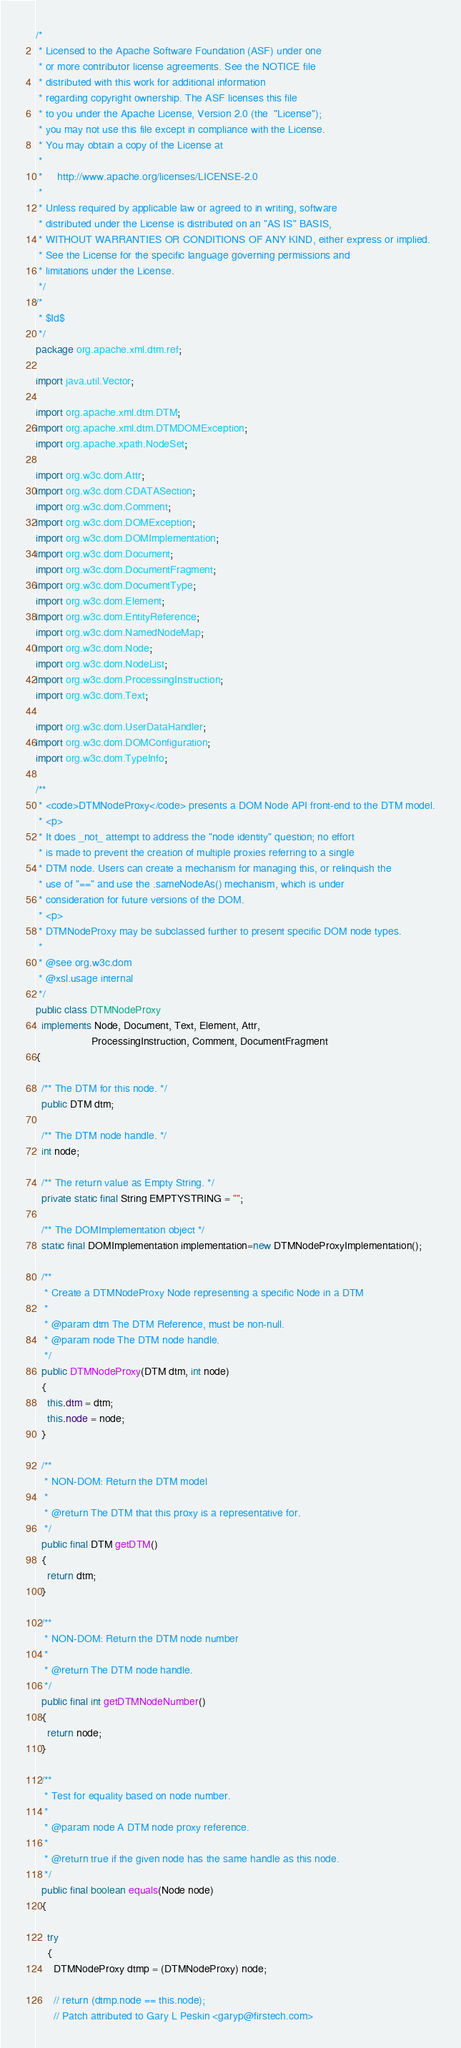<code> <loc_0><loc_0><loc_500><loc_500><_Java_>/*
 * Licensed to the Apache Software Foundation (ASF) under one
 * or more contributor license agreements. See the NOTICE file
 * distributed with this work for additional information
 * regarding copyright ownership. The ASF licenses this file
 * to you under the Apache License, Version 2.0 (the  "License");
 * you may not use this file except in compliance with the License.
 * You may obtain a copy of the License at
 *
 *     http://www.apache.org/licenses/LICENSE-2.0
 *
 * Unless required by applicable law or agreed to in writing, software
 * distributed under the License is distributed on an "AS IS" BASIS,
 * WITHOUT WARRANTIES OR CONDITIONS OF ANY KIND, either express or implied.
 * See the License for the specific language governing permissions and
 * limitations under the License.
 */
/*
 * $Id$
 */
package org.apache.xml.dtm.ref;

import java.util.Vector;

import org.apache.xml.dtm.DTM;
import org.apache.xml.dtm.DTMDOMException;
import org.apache.xpath.NodeSet;

import org.w3c.dom.Attr;
import org.w3c.dom.CDATASection;
import org.w3c.dom.Comment;
import org.w3c.dom.DOMException;
import org.w3c.dom.DOMImplementation;
import org.w3c.dom.Document;
import org.w3c.dom.DocumentFragment;
import org.w3c.dom.DocumentType;
import org.w3c.dom.Element;
import org.w3c.dom.EntityReference;
import org.w3c.dom.NamedNodeMap;
import org.w3c.dom.Node;
import org.w3c.dom.NodeList;
import org.w3c.dom.ProcessingInstruction;
import org.w3c.dom.Text;

import org.w3c.dom.UserDataHandler;
import org.w3c.dom.DOMConfiguration;
import org.w3c.dom.TypeInfo;

/**
 * <code>DTMNodeProxy</code> presents a DOM Node API front-end to the DTM model.
 * <p>
 * It does _not_ attempt to address the "node identity" question; no effort
 * is made to prevent the creation of multiple proxies referring to a single
 * DTM node. Users can create a mechanism for managing this, or relinquish the
 * use of "==" and use the .sameNodeAs() mechanism, which is under
 * consideration for future versions of the DOM.
 * <p>
 * DTMNodeProxy may be subclassed further to present specific DOM node types.
 *
 * @see org.w3c.dom
 * @xsl.usage internal
 */
public class DTMNodeProxy
  implements Node, Document, Text, Element, Attr,
                   ProcessingInstruction, Comment, DocumentFragment
{

  /** The DTM for this node. */
  public DTM dtm;

  /** The DTM node handle. */
  int node;
  
  /** The return value as Empty String. */
  private static final String EMPTYSTRING = "";
          
  /** The DOMImplementation object */
  static final DOMImplementation implementation=new DTMNodeProxyImplementation();

  /**
   * Create a DTMNodeProxy Node representing a specific Node in a DTM
   *
   * @param dtm The DTM Reference, must be non-null.
   * @param node The DTM node handle.
   */
  public DTMNodeProxy(DTM dtm, int node)
  {
    this.dtm = dtm;
    this.node = node;
  }

  /**
   * NON-DOM: Return the DTM model
   *
   * @return The DTM that this proxy is a representative for.
   */
  public final DTM getDTM()
  {
    return dtm;
  }

  /**
   * NON-DOM: Return the DTM node number
   *
   * @return The DTM node handle.
   */
  public final int getDTMNodeNumber()
  {
    return node;
  }

  /**
   * Test for equality based on node number.
   *
   * @param node A DTM node proxy reference.
   *
   * @return true if the given node has the same handle as this node.
   */
  public final boolean equals(Node node)
  {

    try
    {
      DTMNodeProxy dtmp = (DTMNodeProxy) node;

      // return (dtmp.node == this.node);
      // Patch attributed to Gary L Peskin <garyp@firstech.com></code> 